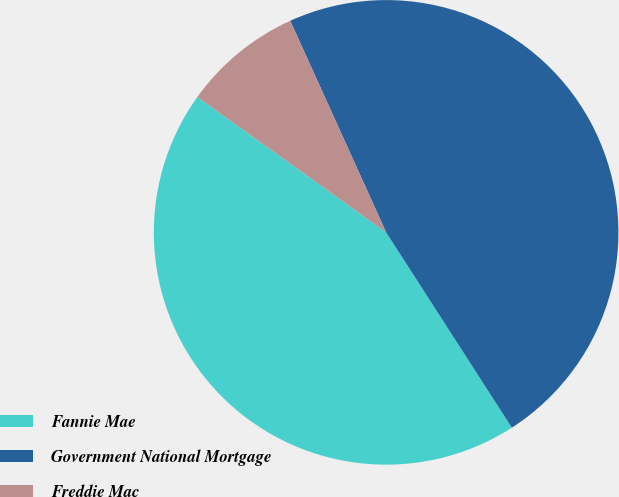Convert chart. <chart><loc_0><loc_0><loc_500><loc_500><pie_chart><fcel>Fannie Mae<fcel>Government National Mortgage<fcel>Freddie Mac<nl><fcel>44.0%<fcel>47.67%<fcel>8.33%<nl></chart> 